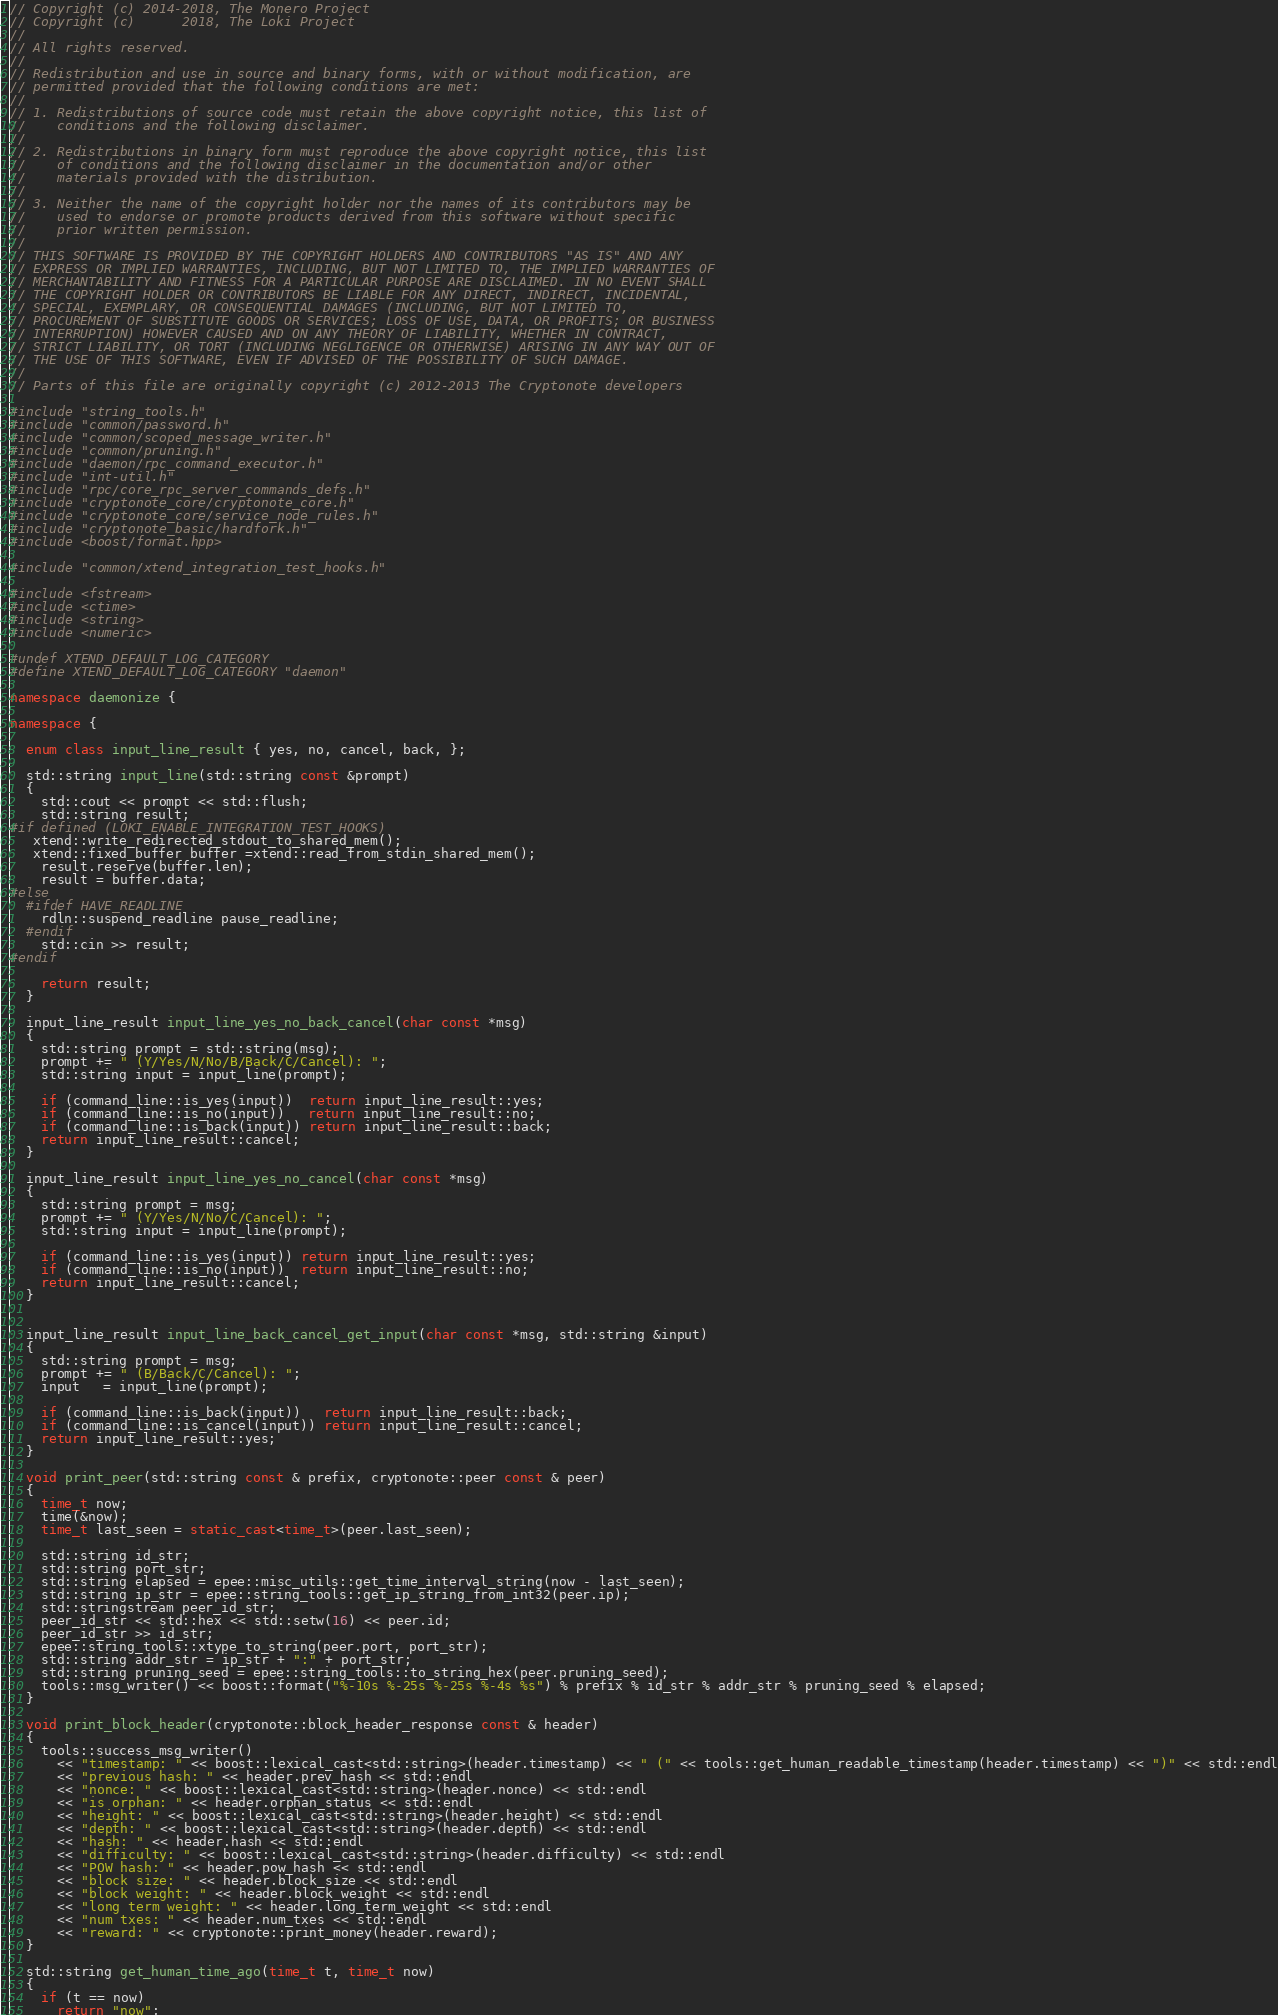Convert code to text. <code><loc_0><loc_0><loc_500><loc_500><_C++_>// Copyright (c) 2014-2018, The Monero Project
// Copyright (c)      2018, The Loki Project
//
// All rights reserved.
//
// Redistribution and use in source and binary forms, with or without modification, are
// permitted provided that the following conditions are met:
//
// 1. Redistributions of source code must retain the above copyright notice, this list of
//    conditions and the following disclaimer.
//
// 2. Redistributions in binary form must reproduce the above copyright notice, this list
//    of conditions and the following disclaimer in the documentation and/or other
//    materials provided with the distribution.
//
// 3. Neither the name of the copyright holder nor the names of its contributors may be
//    used to endorse or promote products derived from this software without specific
//    prior written permission.
//
// THIS SOFTWARE IS PROVIDED BY THE COPYRIGHT HOLDERS AND CONTRIBUTORS "AS IS" AND ANY
// EXPRESS OR IMPLIED WARRANTIES, INCLUDING, BUT NOT LIMITED TO, THE IMPLIED WARRANTIES OF
// MERCHANTABILITY AND FITNESS FOR A PARTICULAR PURPOSE ARE DISCLAIMED. IN NO EVENT SHALL
// THE COPYRIGHT HOLDER OR CONTRIBUTORS BE LIABLE FOR ANY DIRECT, INDIRECT, INCIDENTAL,
// SPECIAL, EXEMPLARY, OR CONSEQUENTIAL DAMAGES (INCLUDING, BUT NOT LIMITED TO,
// PROCUREMENT OF SUBSTITUTE GOODS OR SERVICES; LOSS OF USE, DATA, OR PROFITS; OR BUSINESS
// INTERRUPTION) HOWEVER CAUSED AND ON ANY THEORY OF LIABILITY, WHETHER IN CONTRACT,
// STRICT LIABILITY, OR TORT (INCLUDING NEGLIGENCE OR OTHERWISE) ARISING IN ANY WAY OUT OF
// THE USE OF THIS SOFTWARE, EVEN IF ADVISED OF THE POSSIBILITY OF SUCH DAMAGE.
//
// Parts of this file are originally copyright (c) 2012-2013 The Cryptonote developers

#include "string_tools.h"
#include "common/password.h"
#include "common/scoped_message_writer.h"
#include "common/pruning.h"
#include "daemon/rpc_command_executor.h"
#include "int-util.h"
#include "rpc/core_rpc_server_commands_defs.h"
#include "cryptonote_core/cryptonote_core.h"
#include "cryptonote_core/service_node_rules.h"
#include "cryptonote_basic/hardfork.h"
#include <boost/format.hpp>

#include "common/xtend_integration_test_hooks.h"

#include <fstream>
#include <ctime>
#include <string>
#include <numeric>

#undef XTEND_DEFAULT_LOG_CATEGORY
#define XTEND_DEFAULT_LOG_CATEGORY "daemon"

namespace daemonize {

namespace {

  enum class input_line_result { yes, no, cancel, back, };

  std::string input_line(std::string const &prompt)
  {
    std::cout << prompt << std::flush;
    std::string result;
#if defined (LOKI_ENABLE_INTEGRATION_TEST_HOOKS)
   xtend::write_redirected_stdout_to_shared_mem();
   xtend::fixed_buffer buffer =xtend::read_from_stdin_shared_mem();
    result.reserve(buffer.len);
    result = buffer.data;
#else
  #ifdef HAVE_READLINE
    rdln::suspend_readline pause_readline;
  #endif
    std::cin >> result;
#endif

    return result;
  }

  input_line_result input_line_yes_no_back_cancel(char const *msg)
  {
    std::string prompt = std::string(msg);
    prompt += " (Y/Yes/N/No/B/Back/C/Cancel): ";
    std::string input = input_line(prompt);

    if (command_line::is_yes(input))  return input_line_result::yes;
    if (command_line::is_no(input))   return input_line_result::no;
    if (command_line::is_back(input)) return input_line_result::back;
    return input_line_result::cancel;
  }

  input_line_result input_line_yes_no_cancel(char const *msg)
  {
    std::string prompt = msg;
    prompt += " (Y/Yes/N/No/C/Cancel): ";
    std::string input = input_line(prompt);

    if (command_line::is_yes(input)) return input_line_result::yes;
    if (command_line::is_no(input))  return input_line_result::no;
    return input_line_result::cancel;
  }


  input_line_result input_line_back_cancel_get_input(char const *msg, std::string &input)
  {
    std::string prompt = msg;
    prompt += " (B/Back/C/Cancel): ";
    input   = input_line(prompt);

    if (command_line::is_back(input))   return input_line_result::back;
    if (command_line::is_cancel(input)) return input_line_result::cancel;
    return input_line_result::yes;
  }

  void print_peer(std::string const & prefix, cryptonote::peer const & peer)
  {
    time_t now;
    time(&now);
    time_t last_seen = static_cast<time_t>(peer.last_seen);

    std::string id_str;
    std::string port_str;
    std::string elapsed = epee::misc_utils::get_time_interval_string(now - last_seen);
    std::string ip_str = epee::string_tools::get_ip_string_from_int32(peer.ip);
    std::stringstream peer_id_str;
    peer_id_str << std::hex << std::setw(16) << peer.id;
    peer_id_str >> id_str;
    epee::string_tools::xtype_to_string(peer.port, port_str);
    std::string addr_str = ip_str + ":" + port_str;
    std::string pruning_seed = epee::string_tools::to_string_hex(peer.pruning_seed);
    tools::msg_writer() << boost::format("%-10s %-25s %-25s %-4s %s") % prefix % id_str % addr_str % pruning_seed % elapsed;
  }

  void print_block_header(cryptonote::block_header_response const & header)
  {
    tools::success_msg_writer()
      << "timestamp: " << boost::lexical_cast<std::string>(header.timestamp) << " (" << tools::get_human_readable_timestamp(header.timestamp) << ")" << std::endl
      << "previous hash: " << header.prev_hash << std::endl
      << "nonce: " << boost::lexical_cast<std::string>(header.nonce) << std::endl
      << "is orphan: " << header.orphan_status << std::endl
      << "height: " << boost::lexical_cast<std::string>(header.height) << std::endl
      << "depth: " << boost::lexical_cast<std::string>(header.depth) << std::endl
      << "hash: " << header.hash << std::endl
      << "difficulty: " << boost::lexical_cast<std::string>(header.difficulty) << std::endl
      << "POW hash: " << header.pow_hash << std::endl
      << "block size: " << header.block_size << std::endl
      << "block weight: " << header.block_weight << std::endl
      << "long term weight: " << header.long_term_weight << std::endl
      << "num txes: " << header.num_txes << std::endl
      << "reward: " << cryptonote::print_money(header.reward);
  }

  std::string get_human_time_ago(time_t t, time_t now)
  {
    if (t == now)
      return "now";</code> 